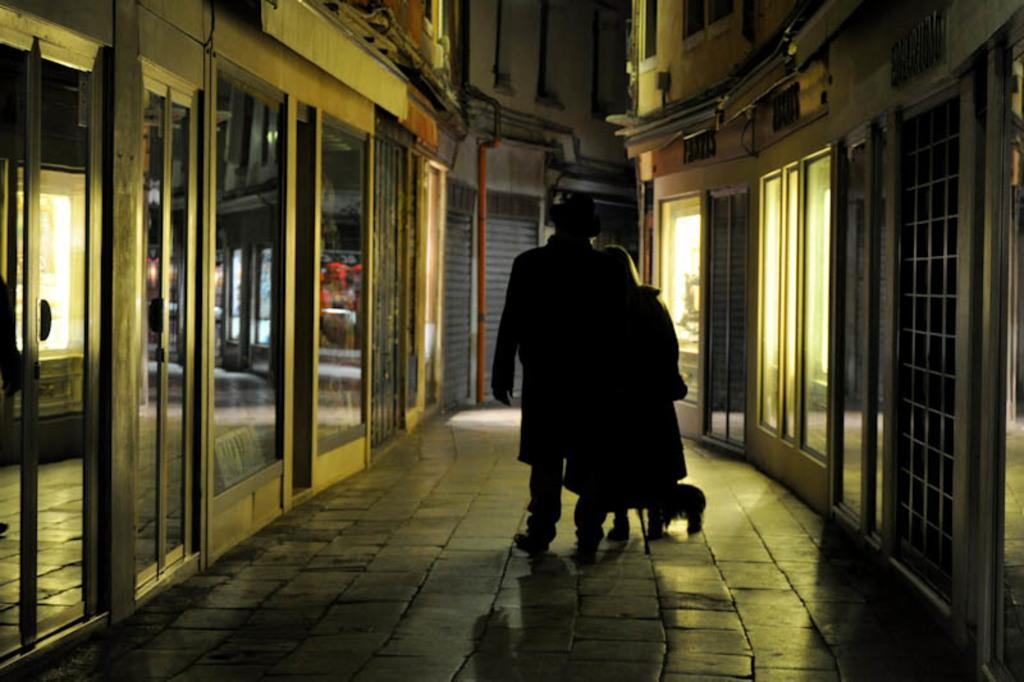What can be inferred about the lighting conditions in the image? The image was taken in a dark environment. How many people are in the image? There are two persons standing in the middle of the image. Where are the persons standing? The persons are standing on the floor. What can be seen in the background of the image? There are buildings visible on both the right and left sides of the image. What riddle does the guide ask the two persons in the image? There is no guide present in the image, and therefore no riddle can be asked. 